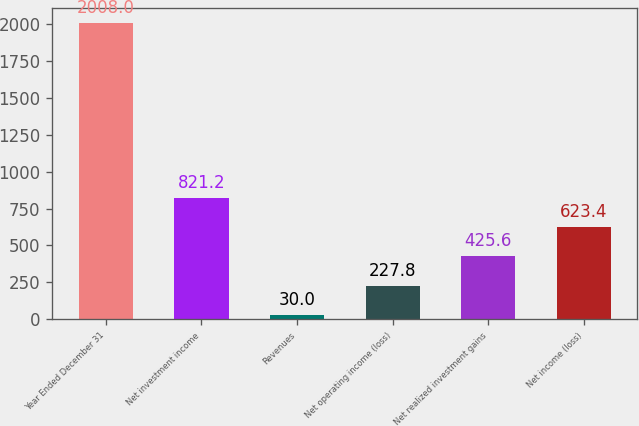<chart> <loc_0><loc_0><loc_500><loc_500><bar_chart><fcel>Year Ended December 31<fcel>Net investment income<fcel>Revenues<fcel>Net operating income (loss)<fcel>Net realized investment gains<fcel>Net income (loss)<nl><fcel>2008<fcel>821.2<fcel>30<fcel>227.8<fcel>425.6<fcel>623.4<nl></chart> 